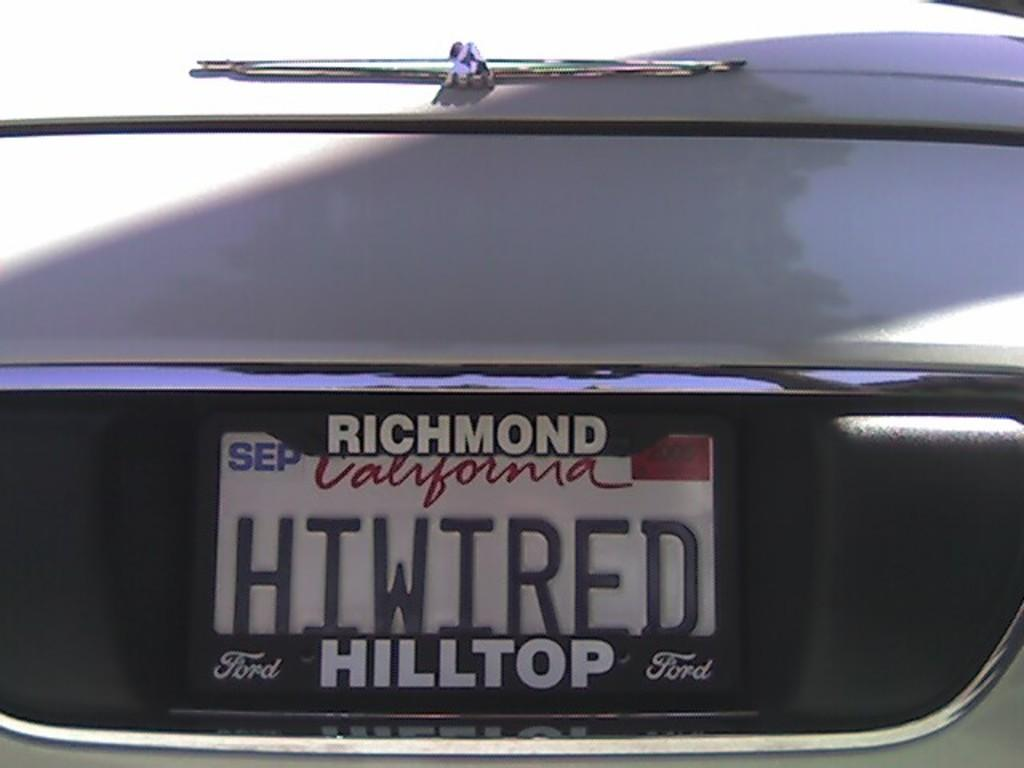<image>
Describe the image concisely. A picture of a California Plate saying HTWIRED. 